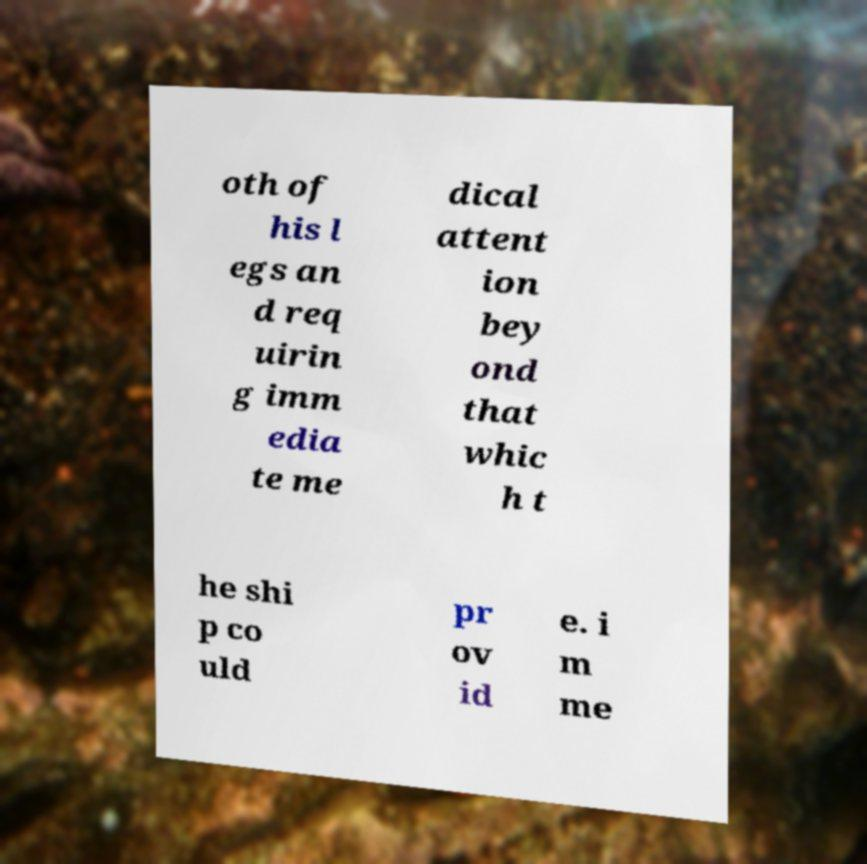Could you assist in decoding the text presented in this image and type it out clearly? oth of his l egs an d req uirin g imm edia te me dical attent ion bey ond that whic h t he shi p co uld pr ov id e. i m me 